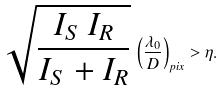Convert formula to latex. <formula><loc_0><loc_0><loc_500><loc_500>\sqrt { \frac { I _ { S } \, I _ { R } } { I _ { S } + I _ { R } } } \, \left ( \frac { \lambda _ { 0 } } { D } \right ) _ { p i x } > \eta .</formula> 